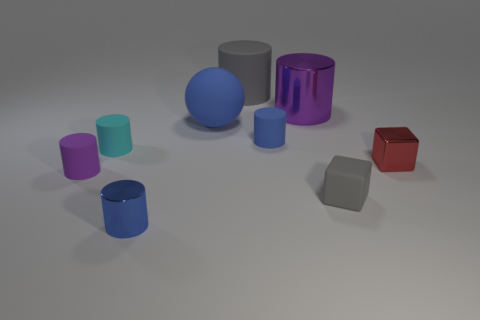Are there any other things that have the same material as the gray cube?
Make the answer very short. Yes. There is a thing behind the purple shiny cylinder; what number of rubber things are in front of it?
Offer a terse response. 5. Do the matte cylinder in front of the small metal cube and the sphere have the same color?
Provide a short and direct response. No. There is a tiny blue thing that is behind the small metallic object behind the small blue metallic cylinder; is there a small blue matte cylinder that is in front of it?
Make the answer very short. No. The tiny thing that is both behind the tiny red block and on the right side of the big sphere has what shape?
Your answer should be compact. Cylinder. Is there another matte sphere that has the same color as the big ball?
Your answer should be compact. No. The tiny block that is to the right of the gray rubber object in front of the small red block is what color?
Give a very brief answer. Red. What is the size of the purple cylinder on the right side of the small blue cylinder that is in front of the matte cylinder on the right side of the gray cylinder?
Keep it short and to the point. Large. Is the gray cube made of the same material as the small blue object that is in front of the tiny red metal thing?
Your response must be concise. No. There is a cyan thing that is made of the same material as the gray cylinder; what is its size?
Your response must be concise. Small. 